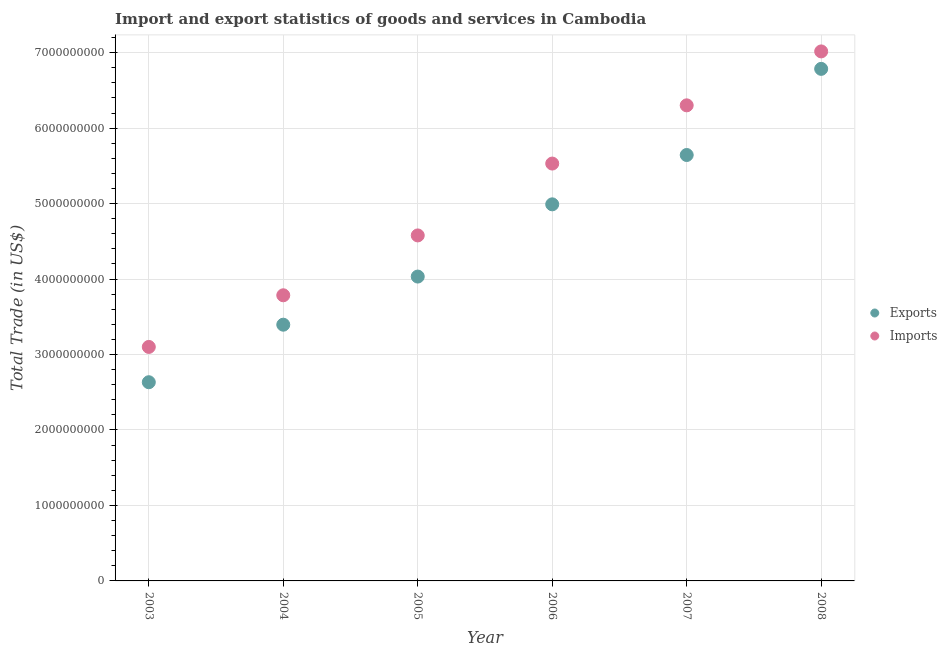How many different coloured dotlines are there?
Make the answer very short. 2. What is the export of goods and services in 2007?
Your response must be concise. 5.64e+09. Across all years, what is the maximum imports of goods and services?
Give a very brief answer. 7.02e+09. Across all years, what is the minimum export of goods and services?
Keep it short and to the point. 2.63e+09. In which year was the export of goods and services maximum?
Make the answer very short. 2008. In which year was the imports of goods and services minimum?
Keep it short and to the point. 2003. What is the total export of goods and services in the graph?
Your answer should be compact. 2.75e+1. What is the difference between the export of goods and services in 2004 and that in 2006?
Your answer should be very brief. -1.59e+09. What is the difference between the export of goods and services in 2003 and the imports of goods and services in 2005?
Provide a succinct answer. -1.95e+09. What is the average imports of goods and services per year?
Your response must be concise. 5.05e+09. In the year 2004, what is the difference between the imports of goods and services and export of goods and services?
Offer a very short reply. 3.90e+08. In how many years, is the export of goods and services greater than 5000000000 US$?
Provide a short and direct response. 2. What is the ratio of the imports of goods and services in 2004 to that in 2005?
Offer a terse response. 0.83. Is the difference between the export of goods and services in 2005 and 2007 greater than the difference between the imports of goods and services in 2005 and 2007?
Give a very brief answer. Yes. What is the difference between the highest and the second highest export of goods and services?
Provide a succinct answer. 1.14e+09. What is the difference between the highest and the lowest imports of goods and services?
Your answer should be compact. 3.92e+09. Is the sum of the export of goods and services in 2004 and 2008 greater than the maximum imports of goods and services across all years?
Offer a terse response. Yes. Does the export of goods and services monotonically increase over the years?
Your response must be concise. Yes. Is the imports of goods and services strictly greater than the export of goods and services over the years?
Make the answer very short. Yes. Is the imports of goods and services strictly less than the export of goods and services over the years?
Give a very brief answer. No. What is the difference between two consecutive major ticks on the Y-axis?
Make the answer very short. 1.00e+09. Are the values on the major ticks of Y-axis written in scientific E-notation?
Your response must be concise. No. Does the graph contain any zero values?
Keep it short and to the point. No. What is the title of the graph?
Keep it short and to the point. Import and export statistics of goods and services in Cambodia. Does "Taxes on profits and capital gains" appear as one of the legend labels in the graph?
Provide a succinct answer. No. What is the label or title of the X-axis?
Your answer should be very brief. Year. What is the label or title of the Y-axis?
Provide a succinct answer. Total Trade (in US$). What is the Total Trade (in US$) in Exports in 2003?
Make the answer very short. 2.63e+09. What is the Total Trade (in US$) of Imports in 2003?
Provide a succinct answer. 3.10e+09. What is the Total Trade (in US$) in Exports in 2004?
Your answer should be compact. 3.40e+09. What is the Total Trade (in US$) in Imports in 2004?
Keep it short and to the point. 3.78e+09. What is the Total Trade (in US$) of Exports in 2005?
Provide a succinct answer. 4.03e+09. What is the Total Trade (in US$) of Imports in 2005?
Keep it short and to the point. 4.58e+09. What is the Total Trade (in US$) in Exports in 2006?
Your answer should be very brief. 4.99e+09. What is the Total Trade (in US$) in Imports in 2006?
Make the answer very short. 5.53e+09. What is the Total Trade (in US$) in Exports in 2007?
Your answer should be very brief. 5.64e+09. What is the Total Trade (in US$) in Imports in 2007?
Provide a succinct answer. 6.30e+09. What is the Total Trade (in US$) of Exports in 2008?
Your answer should be very brief. 6.78e+09. What is the Total Trade (in US$) in Imports in 2008?
Your answer should be very brief. 7.02e+09. Across all years, what is the maximum Total Trade (in US$) in Exports?
Ensure brevity in your answer.  6.78e+09. Across all years, what is the maximum Total Trade (in US$) of Imports?
Give a very brief answer. 7.02e+09. Across all years, what is the minimum Total Trade (in US$) in Exports?
Provide a short and direct response. 2.63e+09. Across all years, what is the minimum Total Trade (in US$) in Imports?
Provide a short and direct response. 3.10e+09. What is the total Total Trade (in US$) in Exports in the graph?
Offer a terse response. 2.75e+1. What is the total Total Trade (in US$) in Imports in the graph?
Offer a very short reply. 3.03e+1. What is the difference between the Total Trade (in US$) of Exports in 2003 and that in 2004?
Your answer should be compact. -7.62e+08. What is the difference between the Total Trade (in US$) of Imports in 2003 and that in 2004?
Provide a succinct answer. -6.84e+08. What is the difference between the Total Trade (in US$) of Exports in 2003 and that in 2005?
Give a very brief answer. -1.40e+09. What is the difference between the Total Trade (in US$) in Imports in 2003 and that in 2005?
Your response must be concise. -1.48e+09. What is the difference between the Total Trade (in US$) of Exports in 2003 and that in 2006?
Provide a short and direct response. -2.36e+09. What is the difference between the Total Trade (in US$) in Imports in 2003 and that in 2006?
Offer a terse response. -2.43e+09. What is the difference between the Total Trade (in US$) of Exports in 2003 and that in 2007?
Give a very brief answer. -3.01e+09. What is the difference between the Total Trade (in US$) in Imports in 2003 and that in 2007?
Your answer should be very brief. -3.20e+09. What is the difference between the Total Trade (in US$) of Exports in 2003 and that in 2008?
Offer a terse response. -4.15e+09. What is the difference between the Total Trade (in US$) of Imports in 2003 and that in 2008?
Make the answer very short. -3.92e+09. What is the difference between the Total Trade (in US$) of Exports in 2004 and that in 2005?
Keep it short and to the point. -6.38e+08. What is the difference between the Total Trade (in US$) of Imports in 2004 and that in 2005?
Ensure brevity in your answer.  -7.93e+08. What is the difference between the Total Trade (in US$) of Exports in 2004 and that in 2006?
Keep it short and to the point. -1.59e+09. What is the difference between the Total Trade (in US$) of Imports in 2004 and that in 2006?
Your answer should be very brief. -1.75e+09. What is the difference between the Total Trade (in US$) in Exports in 2004 and that in 2007?
Offer a terse response. -2.25e+09. What is the difference between the Total Trade (in US$) in Imports in 2004 and that in 2007?
Make the answer very short. -2.52e+09. What is the difference between the Total Trade (in US$) in Exports in 2004 and that in 2008?
Ensure brevity in your answer.  -3.39e+09. What is the difference between the Total Trade (in US$) in Imports in 2004 and that in 2008?
Provide a succinct answer. -3.23e+09. What is the difference between the Total Trade (in US$) of Exports in 2005 and that in 2006?
Offer a terse response. -9.57e+08. What is the difference between the Total Trade (in US$) in Imports in 2005 and that in 2006?
Make the answer very short. -9.52e+08. What is the difference between the Total Trade (in US$) in Exports in 2005 and that in 2007?
Offer a very short reply. -1.61e+09. What is the difference between the Total Trade (in US$) of Imports in 2005 and that in 2007?
Make the answer very short. -1.72e+09. What is the difference between the Total Trade (in US$) of Exports in 2005 and that in 2008?
Your answer should be compact. -2.75e+09. What is the difference between the Total Trade (in US$) in Imports in 2005 and that in 2008?
Your response must be concise. -2.44e+09. What is the difference between the Total Trade (in US$) of Exports in 2006 and that in 2007?
Offer a very short reply. -6.54e+08. What is the difference between the Total Trade (in US$) of Imports in 2006 and that in 2007?
Provide a succinct answer. -7.71e+08. What is the difference between the Total Trade (in US$) in Exports in 2006 and that in 2008?
Your answer should be very brief. -1.80e+09. What is the difference between the Total Trade (in US$) of Imports in 2006 and that in 2008?
Provide a succinct answer. -1.49e+09. What is the difference between the Total Trade (in US$) of Exports in 2007 and that in 2008?
Keep it short and to the point. -1.14e+09. What is the difference between the Total Trade (in US$) in Imports in 2007 and that in 2008?
Give a very brief answer. -7.15e+08. What is the difference between the Total Trade (in US$) of Exports in 2003 and the Total Trade (in US$) of Imports in 2004?
Ensure brevity in your answer.  -1.15e+09. What is the difference between the Total Trade (in US$) of Exports in 2003 and the Total Trade (in US$) of Imports in 2005?
Your answer should be very brief. -1.95e+09. What is the difference between the Total Trade (in US$) of Exports in 2003 and the Total Trade (in US$) of Imports in 2006?
Offer a very short reply. -2.90e+09. What is the difference between the Total Trade (in US$) of Exports in 2003 and the Total Trade (in US$) of Imports in 2007?
Provide a short and direct response. -3.67e+09. What is the difference between the Total Trade (in US$) in Exports in 2003 and the Total Trade (in US$) in Imports in 2008?
Your answer should be very brief. -4.38e+09. What is the difference between the Total Trade (in US$) of Exports in 2004 and the Total Trade (in US$) of Imports in 2005?
Offer a very short reply. -1.18e+09. What is the difference between the Total Trade (in US$) of Exports in 2004 and the Total Trade (in US$) of Imports in 2006?
Make the answer very short. -2.14e+09. What is the difference between the Total Trade (in US$) in Exports in 2004 and the Total Trade (in US$) in Imports in 2007?
Your answer should be very brief. -2.91e+09. What is the difference between the Total Trade (in US$) in Exports in 2004 and the Total Trade (in US$) in Imports in 2008?
Provide a succinct answer. -3.62e+09. What is the difference between the Total Trade (in US$) of Exports in 2005 and the Total Trade (in US$) of Imports in 2006?
Ensure brevity in your answer.  -1.50e+09. What is the difference between the Total Trade (in US$) in Exports in 2005 and the Total Trade (in US$) in Imports in 2007?
Keep it short and to the point. -2.27e+09. What is the difference between the Total Trade (in US$) in Exports in 2005 and the Total Trade (in US$) in Imports in 2008?
Offer a terse response. -2.98e+09. What is the difference between the Total Trade (in US$) in Exports in 2006 and the Total Trade (in US$) in Imports in 2007?
Offer a very short reply. -1.31e+09. What is the difference between the Total Trade (in US$) in Exports in 2006 and the Total Trade (in US$) in Imports in 2008?
Provide a short and direct response. -2.03e+09. What is the difference between the Total Trade (in US$) of Exports in 2007 and the Total Trade (in US$) of Imports in 2008?
Make the answer very short. -1.37e+09. What is the average Total Trade (in US$) in Exports per year?
Your answer should be very brief. 4.58e+09. What is the average Total Trade (in US$) in Imports per year?
Your response must be concise. 5.05e+09. In the year 2003, what is the difference between the Total Trade (in US$) of Exports and Total Trade (in US$) of Imports?
Keep it short and to the point. -4.68e+08. In the year 2004, what is the difference between the Total Trade (in US$) in Exports and Total Trade (in US$) in Imports?
Provide a short and direct response. -3.90e+08. In the year 2005, what is the difference between the Total Trade (in US$) of Exports and Total Trade (in US$) of Imports?
Your answer should be very brief. -5.45e+08. In the year 2006, what is the difference between the Total Trade (in US$) in Exports and Total Trade (in US$) in Imports?
Make the answer very short. -5.40e+08. In the year 2007, what is the difference between the Total Trade (in US$) of Exports and Total Trade (in US$) of Imports?
Your answer should be compact. -6.58e+08. In the year 2008, what is the difference between the Total Trade (in US$) of Exports and Total Trade (in US$) of Imports?
Make the answer very short. -2.31e+08. What is the ratio of the Total Trade (in US$) of Exports in 2003 to that in 2004?
Provide a succinct answer. 0.78. What is the ratio of the Total Trade (in US$) of Imports in 2003 to that in 2004?
Give a very brief answer. 0.82. What is the ratio of the Total Trade (in US$) in Exports in 2003 to that in 2005?
Keep it short and to the point. 0.65. What is the ratio of the Total Trade (in US$) in Imports in 2003 to that in 2005?
Offer a very short reply. 0.68. What is the ratio of the Total Trade (in US$) in Exports in 2003 to that in 2006?
Make the answer very short. 0.53. What is the ratio of the Total Trade (in US$) of Imports in 2003 to that in 2006?
Your response must be concise. 0.56. What is the ratio of the Total Trade (in US$) in Exports in 2003 to that in 2007?
Your answer should be very brief. 0.47. What is the ratio of the Total Trade (in US$) in Imports in 2003 to that in 2007?
Keep it short and to the point. 0.49. What is the ratio of the Total Trade (in US$) in Exports in 2003 to that in 2008?
Your answer should be compact. 0.39. What is the ratio of the Total Trade (in US$) in Imports in 2003 to that in 2008?
Ensure brevity in your answer.  0.44. What is the ratio of the Total Trade (in US$) in Exports in 2004 to that in 2005?
Your answer should be compact. 0.84. What is the ratio of the Total Trade (in US$) in Imports in 2004 to that in 2005?
Make the answer very short. 0.83. What is the ratio of the Total Trade (in US$) in Exports in 2004 to that in 2006?
Give a very brief answer. 0.68. What is the ratio of the Total Trade (in US$) of Imports in 2004 to that in 2006?
Give a very brief answer. 0.68. What is the ratio of the Total Trade (in US$) of Exports in 2004 to that in 2007?
Give a very brief answer. 0.6. What is the ratio of the Total Trade (in US$) of Imports in 2004 to that in 2007?
Make the answer very short. 0.6. What is the ratio of the Total Trade (in US$) of Exports in 2004 to that in 2008?
Your answer should be very brief. 0.5. What is the ratio of the Total Trade (in US$) of Imports in 2004 to that in 2008?
Ensure brevity in your answer.  0.54. What is the ratio of the Total Trade (in US$) in Exports in 2005 to that in 2006?
Your answer should be compact. 0.81. What is the ratio of the Total Trade (in US$) of Imports in 2005 to that in 2006?
Ensure brevity in your answer.  0.83. What is the ratio of the Total Trade (in US$) of Exports in 2005 to that in 2007?
Give a very brief answer. 0.71. What is the ratio of the Total Trade (in US$) of Imports in 2005 to that in 2007?
Offer a terse response. 0.73. What is the ratio of the Total Trade (in US$) of Exports in 2005 to that in 2008?
Offer a terse response. 0.59. What is the ratio of the Total Trade (in US$) in Imports in 2005 to that in 2008?
Give a very brief answer. 0.65. What is the ratio of the Total Trade (in US$) of Exports in 2006 to that in 2007?
Your answer should be compact. 0.88. What is the ratio of the Total Trade (in US$) of Imports in 2006 to that in 2007?
Your response must be concise. 0.88. What is the ratio of the Total Trade (in US$) in Exports in 2006 to that in 2008?
Make the answer very short. 0.74. What is the ratio of the Total Trade (in US$) of Imports in 2006 to that in 2008?
Offer a terse response. 0.79. What is the ratio of the Total Trade (in US$) of Exports in 2007 to that in 2008?
Keep it short and to the point. 0.83. What is the ratio of the Total Trade (in US$) in Imports in 2007 to that in 2008?
Keep it short and to the point. 0.9. What is the difference between the highest and the second highest Total Trade (in US$) in Exports?
Your response must be concise. 1.14e+09. What is the difference between the highest and the second highest Total Trade (in US$) of Imports?
Make the answer very short. 7.15e+08. What is the difference between the highest and the lowest Total Trade (in US$) of Exports?
Give a very brief answer. 4.15e+09. What is the difference between the highest and the lowest Total Trade (in US$) in Imports?
Make the answer very short. 3.92e+09. 